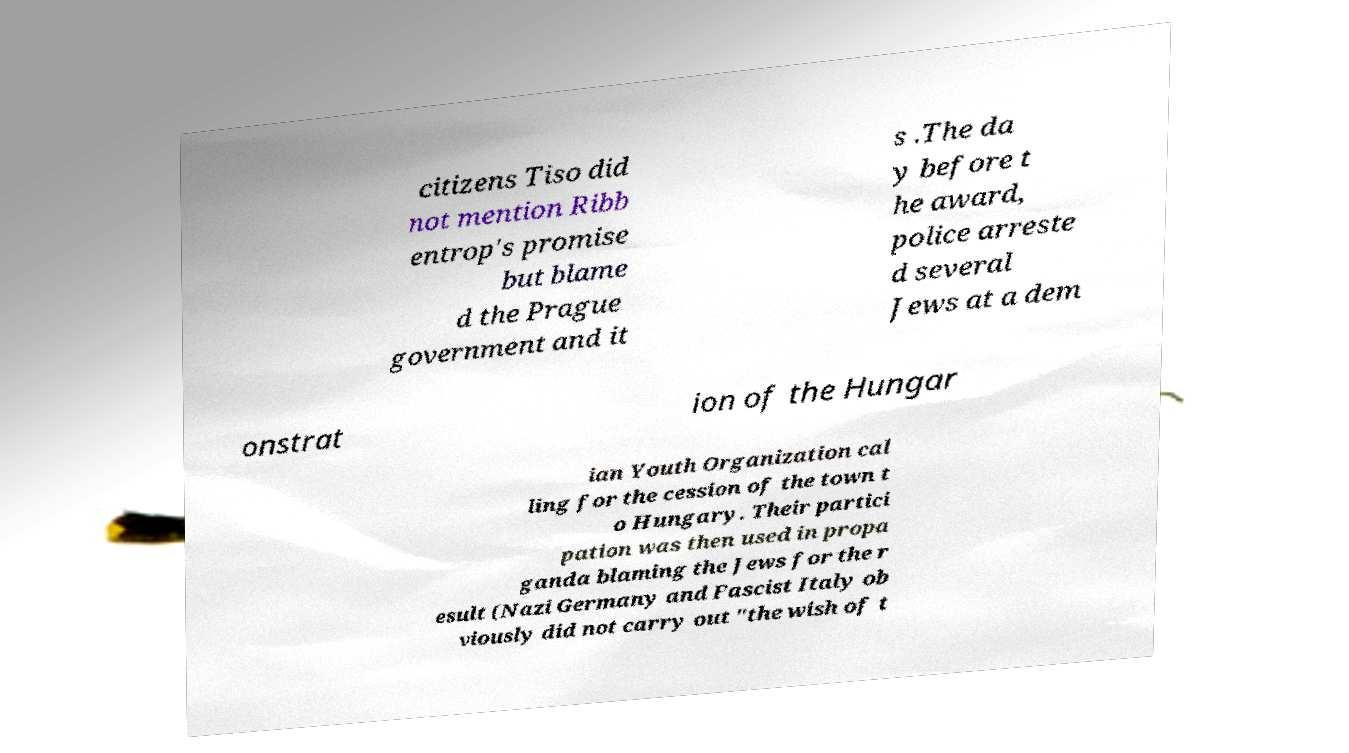For documentation purposes, I need the text within this image transcribed. Could you provide that? citizens Tiso did not mention Ribb entrop's promise but blame d the Prague government and it s .The da y before t he award, police arreste d several Jews at a dem onstrat ion of the Hungar ian Youth Organization cal ling for the cession of the town t o Hungary. Their partici pation was then used in propa ganda blaming the Jews for the r esult (Nazi Germany and Fascist Italy ob viously did not carry out "the wish of t 